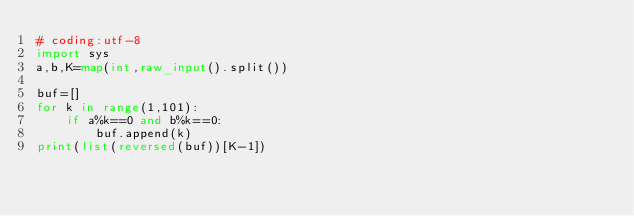<code> <loc_0><loc_0><loc_500><loc_500><_Python_># coding:utf-8
import sys
a,b,K=map(int,raw_input().split())

buf=[]
for k in range(1,101):
    if a%k==0 and b%k==0:
        buf.append(k)
print(list(reversed(buf))[K-1])</code> 